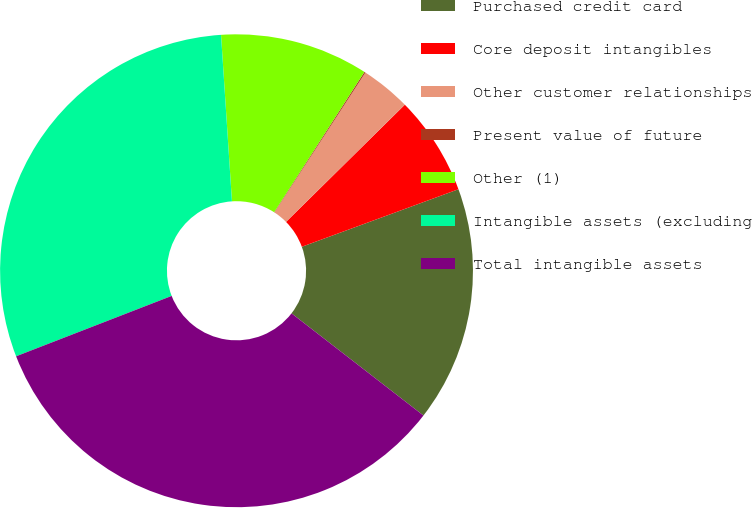Convert chart. <chart><loc_0><loc_0><loc_500><loc_500><pie_chart><fcel>Purchased credit card<fcel>Core deposit intangibles<fcel>Other customer relationships<fcel>Present value of future<fcel>Other (1)<fcel>Intangible assets (excluding<fcel>Total intangible assets<nl><fcel>16.09%<fcel>6.79%<fcel>3.43%<fcel>0.08%<fcel>10.14%<fcel>29.85%<fcel>33.62%<nl></chart> 